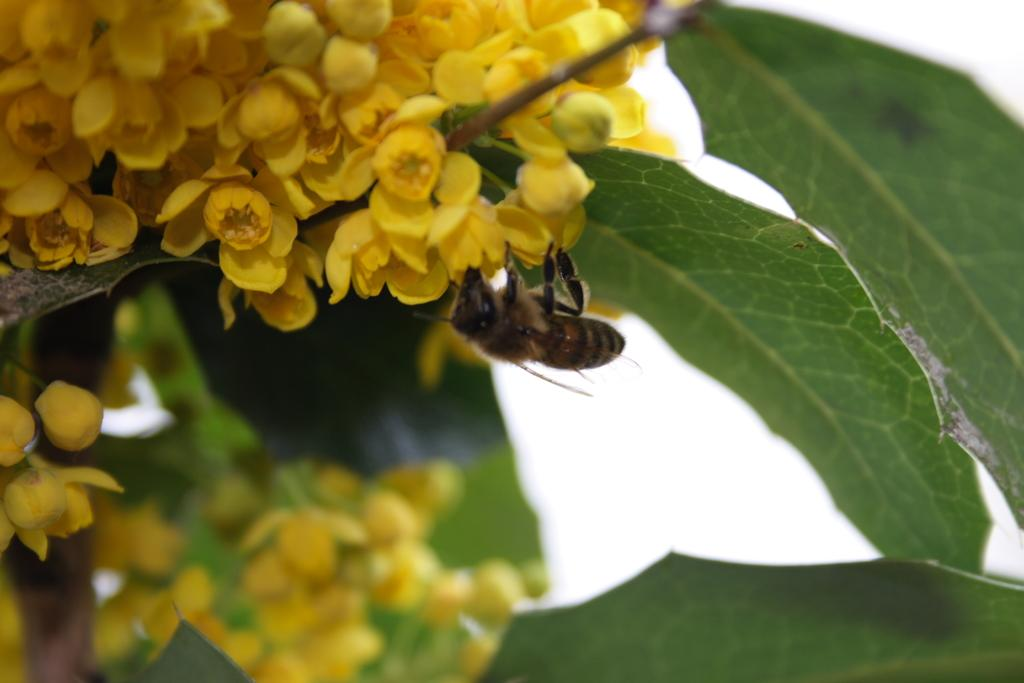What type of plants can be seen in the image? There are flowers in the image. Is there any wildlife interacting with the flowers? Yes, there is a bee on the flowers. What other parts of the plants are visible in the image? There are leaves in the image. What can be seen in the background of the image? The sky is visible in the background. Can you tell me how many people are smiling in the image? There are no people present in the image, so it is not possible to determine how many people might be smiling. 